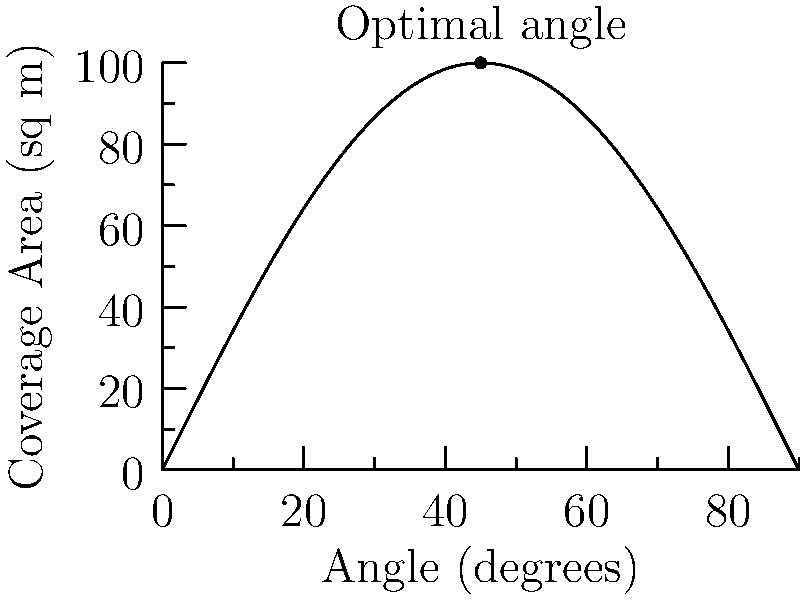The graph shows the relationship between the angle of a security camera and its coverage area in square meters. Find the angle that maximizes the coverage area and determine the maximum coverage area. What is the rate of change of the coverage area with respect to the angle at this optimal point? 1) The graph represents the function $A(\theta) = 100\sin(2\theta\pi/180)$, where $A$ is the coverage area in square meters and $\theta$ is the angle in degrees.

2) To find the maximum, we need to find where $\frac{dA}{d\theta} = 0$:

   $\frac{dA}{d\theta} = 100 \cdot \frac{2\pi}{180} \cos(2\theta\pi/180)$

3) Setting this to zero:

   $100 \cdot \frac{2\pi}{180} \cos(2\theta\pi/180) = 0$
   $\cos(2\theta\pi/180) = 0$

4) This occurs when $2\theta\pi/180 = \pi/2$, or when $\theta = 45°$

5) The maximum coverage area is:

   $A(45°) = 100\sin(2 \cdot 45 \cdot \pi/180) = 100\sin(\pi/2) = 100$ sq m

6) To find the rate of change at this point, we evaluate the derivative at $\theta = 45°$:

   $\frac{dA}{d\theta}|_{\theta=45°} = 100 \cdot \frac{2\pi}{180} \cos(2 \cdot 45 \cdot \pi/180) = 100 \cdot \frac{2\pi}{180} \cos(\pi/2) = 0$
Answer: Optimal angle: 45°; Maximum coverage: 100 sq m; Rate of change at optimal point: 0 sq m/degree 